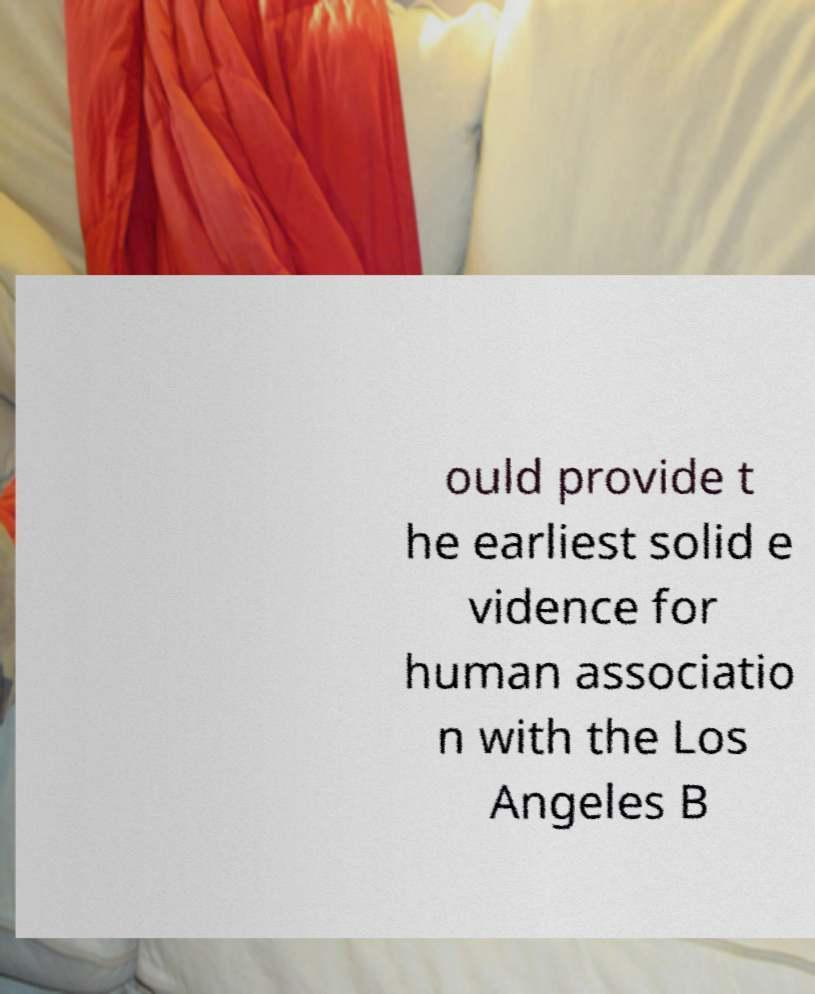There's text embedded in this image that I need extracted. Can you transcribe it verbatim? ould provide t he earliest solid e vidence for human associatio n with the Los Angeles B 